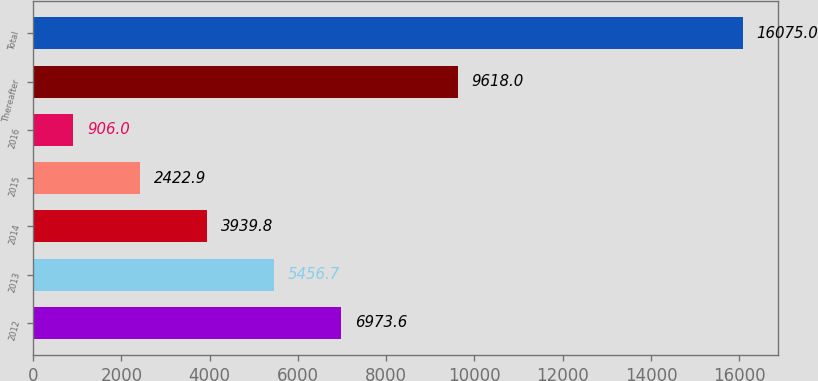Convert chart. <chart><loc_0><loc_0><loc_500><loc_500><bar_chart><fcel>2012<fcel>2013<fcel>2014<fcel>2015<fcel>2016<fcel>Thereafter<fcel>Total<nl><fcel>6973.6<fcel>5456.7<fcel>3939.8<fcel>2422.9<fcel>906<fcel>9618<fcel>16075<nl></chart> 